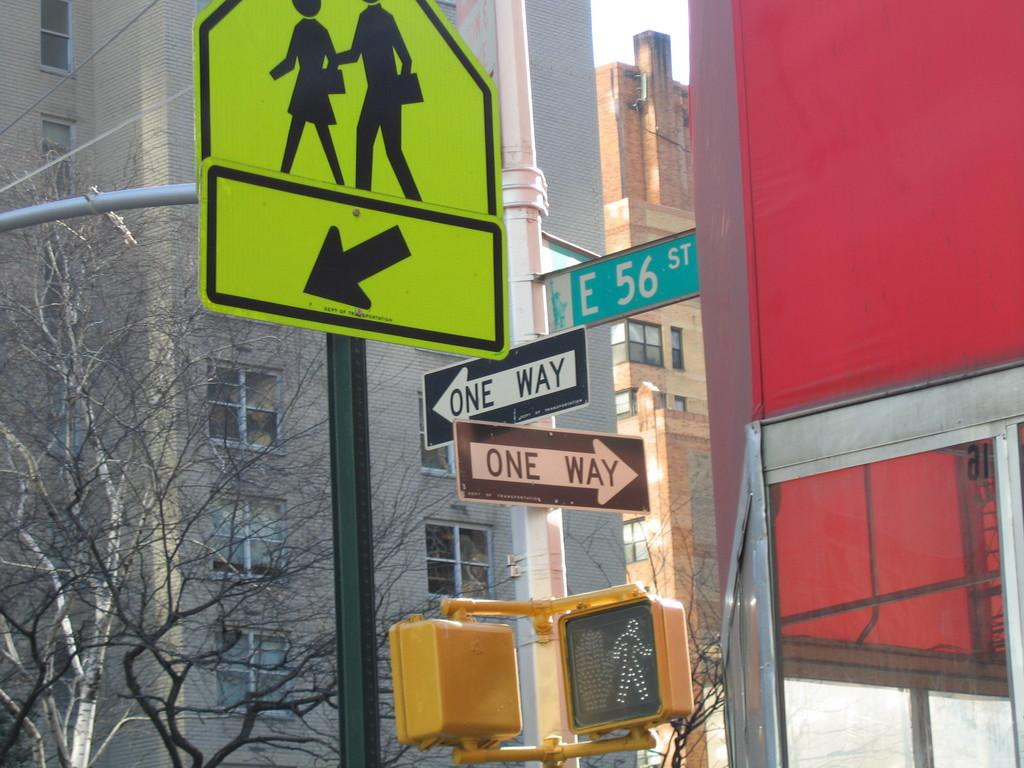Provide a one-sentence caption for the provided image. A pole has two one-way signs as well as a street sign for E 56 st. 